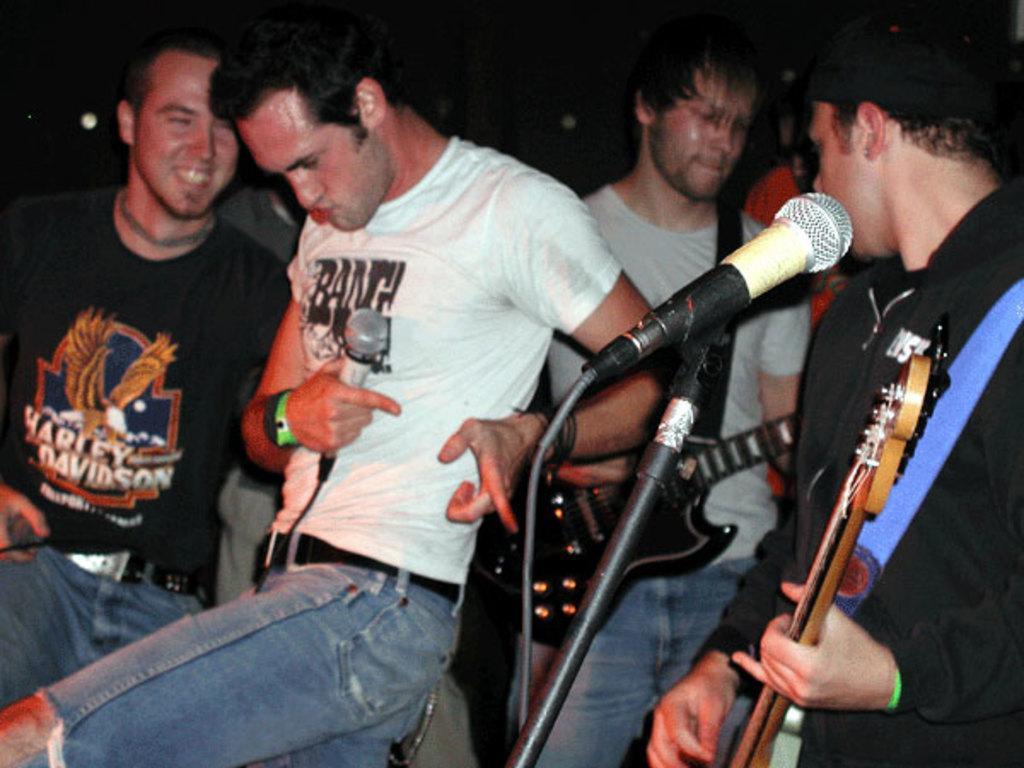In one or two sentences, can you explain what this image depicts? This person is playing guitar. This man is holding a mic. These persons are standing. 